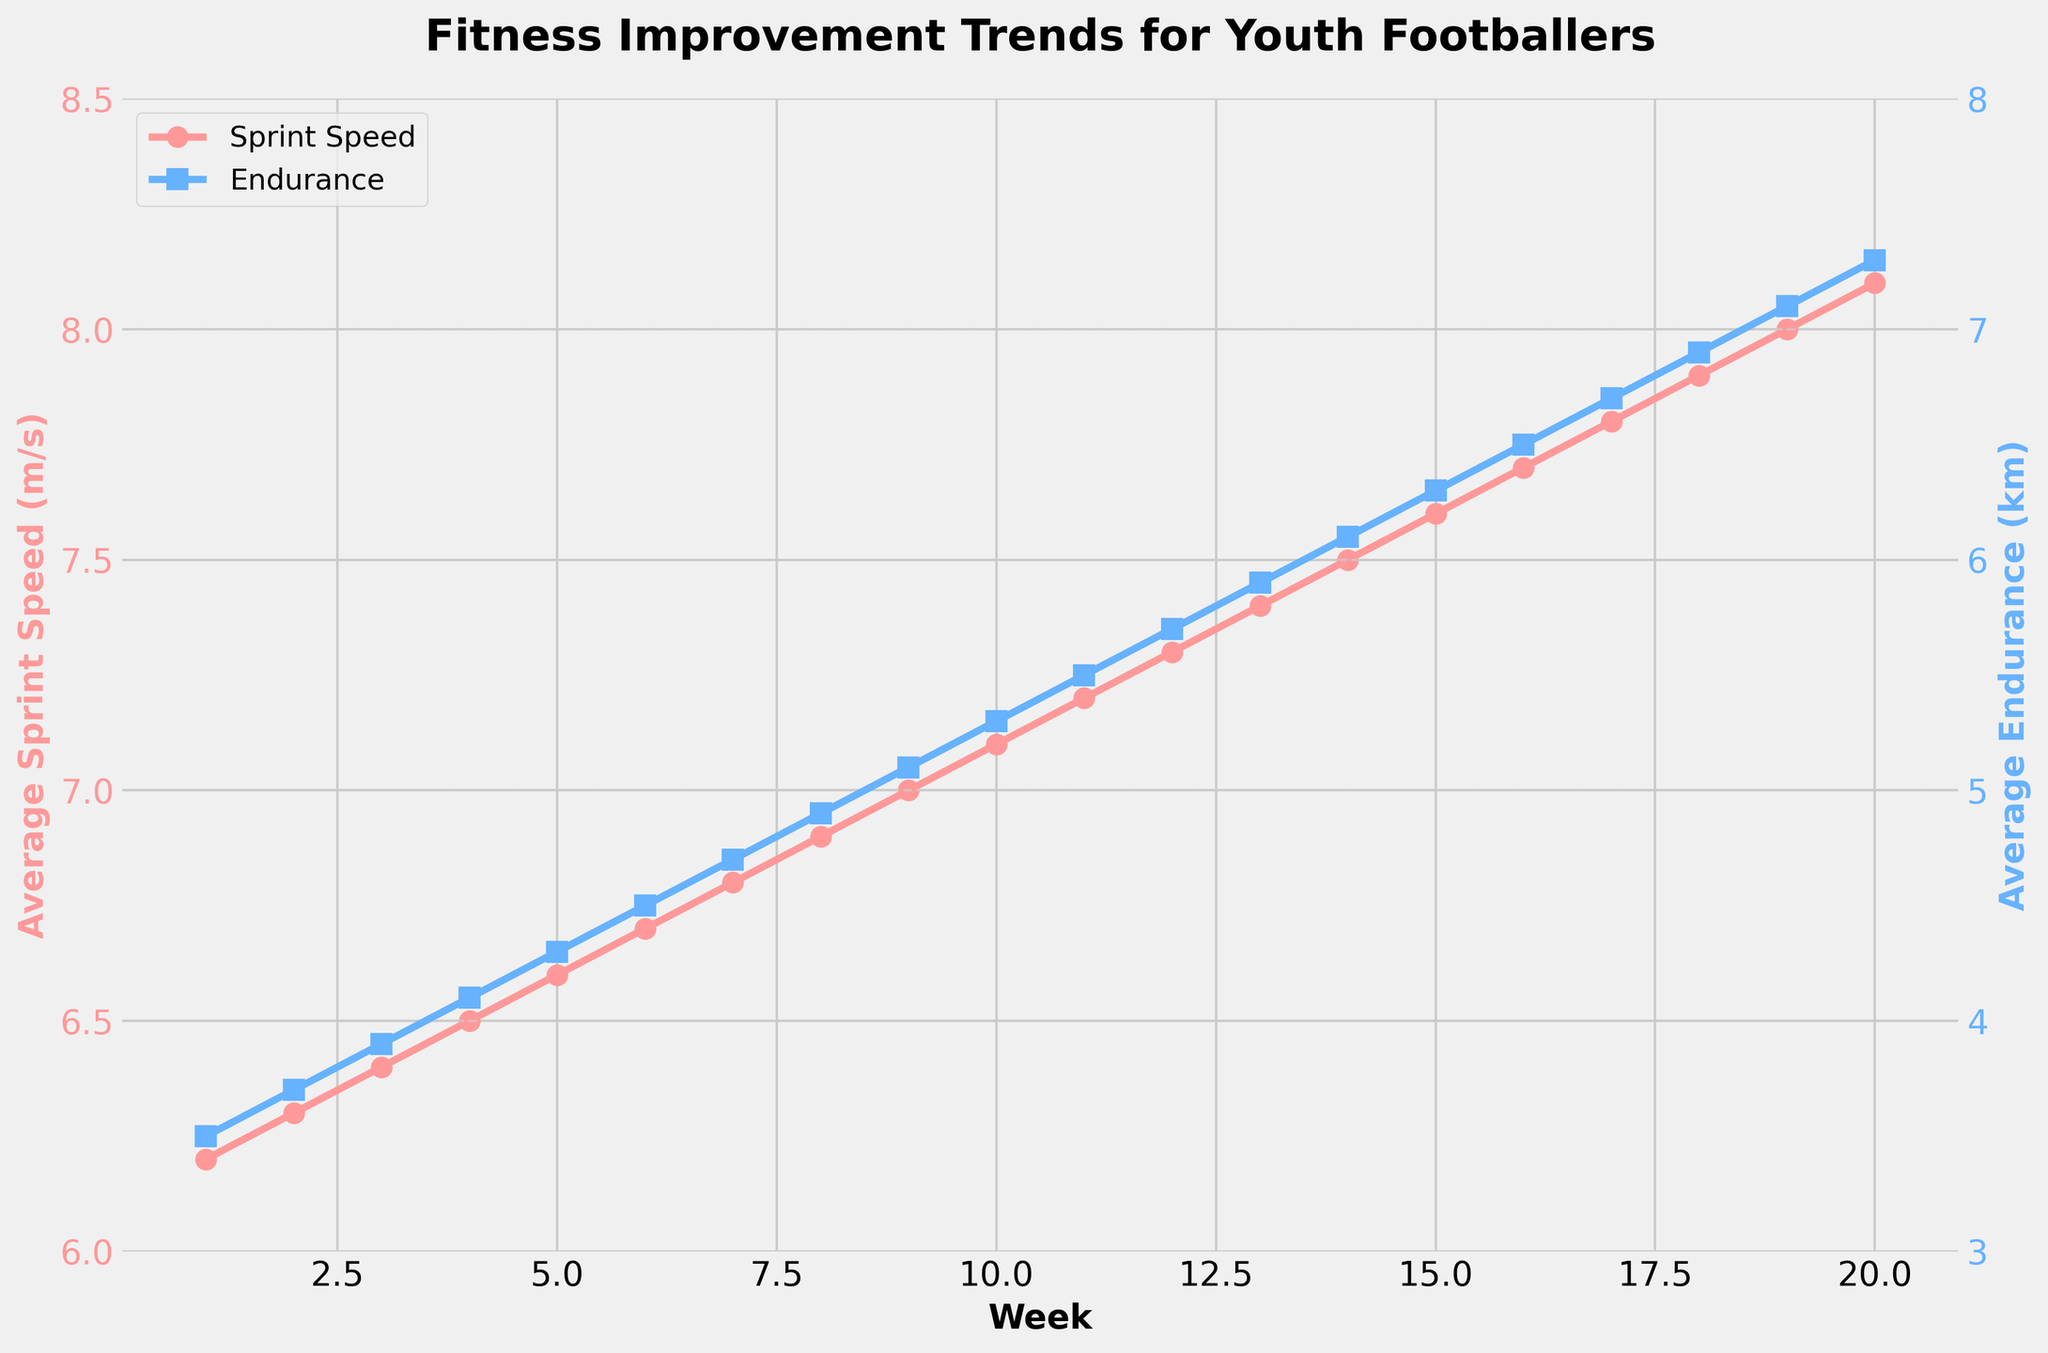what is the trend for average sprint speed over the weeks? Observing the plot, average sprint speed increases over the weeks from 6.2 m/s in Week 1 to 8.1 m/s in Week 20.
Answer: increasing What week did the average endurance surpass 5 km? From the plot, Week 9 shows the average endurance at 5.1 km, which is the first time it surpasses 5 km.
Answer: Week 9 Compare the improvement in sprint speed to the improvement in endurance from Week 1 to Week 20. Sprint speed improved from 6.2 m/s to 8.1 m/s (a 1.9 m/s increase), whereas endurance improved from 3.5 km to 7.3 km (a 3.8 km increase).
Answer: Sprint speed: 1.9 m/s, Endurance: 3.8 km In which week do the average sprint speed and endurance have the smallest gap? The smallest gap is observed in Week 1, where the sprint speed is 6.2 m/s and endurance is 3.5 km, resulting in a gap of 2.7 units.
Answer: Week 1 What colors are used to represent sprint speed and endurance in the plot? Sprint speed is represented by a red line with circle markers, and endurance is represented by a blue line with square markers.
Answer: red and blue What is the difference in average sprint speed between Week 5 and Week 15? In Week 5, the sprint speed is 6.6 m/s, and in Week 15, it is 7.6 m/s. The difference between them is 7.6 - 6.6 = 1.0 m/s.
Answer: 1.0 m/s What is the slope of the trend line for average endurance from Week 10 to Week 20? From the plot, average endurance increased from 5.3 km in Week 10 to 7.3 km in Week 20. The slope is calculated by (7.3 - 5.3) / (20 - 10) = 0.2 km per week.
Answer: 0.2 km per week How does the sprint speed in Week 12 compare with the sprint speed in Week 4? In Week 12, the sprint speed is 7.3 m/s, whereas in Week 4, it is 6.5 m/s. The sprint speed in Week 12 is greater by 0.8 m/s.
Answer: Week 12 is 0.8 m/s greater Describing the overall trends, how do the improvements in sprint speed and endurance compare from the start to the end of the training season? Both sprint speed and endurance show consistent improvement over 20 weeks. Sprint speed increases by 1.9 m/s, while endurance increases by 3.8 km. The overall rate of improvement for endurance appears higher than sprint speed.
Answer: Endurance improves more overall How are the trends in average sprint speed and endurance visually represented in the plot? The trends are represented by two lines: a red line with circles for sprint speed and a blue line with squares for endurance, both rising from left to right.
Answer: red line with circles, blue line with squares 